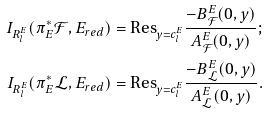<formula> <loc_0><loc_0><loc_500><loc_500>I _ { R _ { l } ^ { E } } ( \pi _ { E } ^ { * } { \mathcal { F } } , E _ { r e d } ) & = \text {Res} _ { y = c _ { l } ^ { E } } \frac { - B _ { \mathcal { F } } ^ { E } ( 0 , y ) } { A _ { \mathcal { F } } ^ { E } ( 0 , y ) } ; \\ I _ { R _ { l } ^ { E } } ( \pi _ { E } ^ { * } { \mathcal { L } } , E _ { r e d } ) & = \text {Res} _ { y = c _ { l } ^ { E } } \frac { - B _ { \mathcal { L } } ^ { E } ( 0 , y ) } { A _ { \mathcal { L } } ^ { E } ( 0 , y ) } .</formula> 